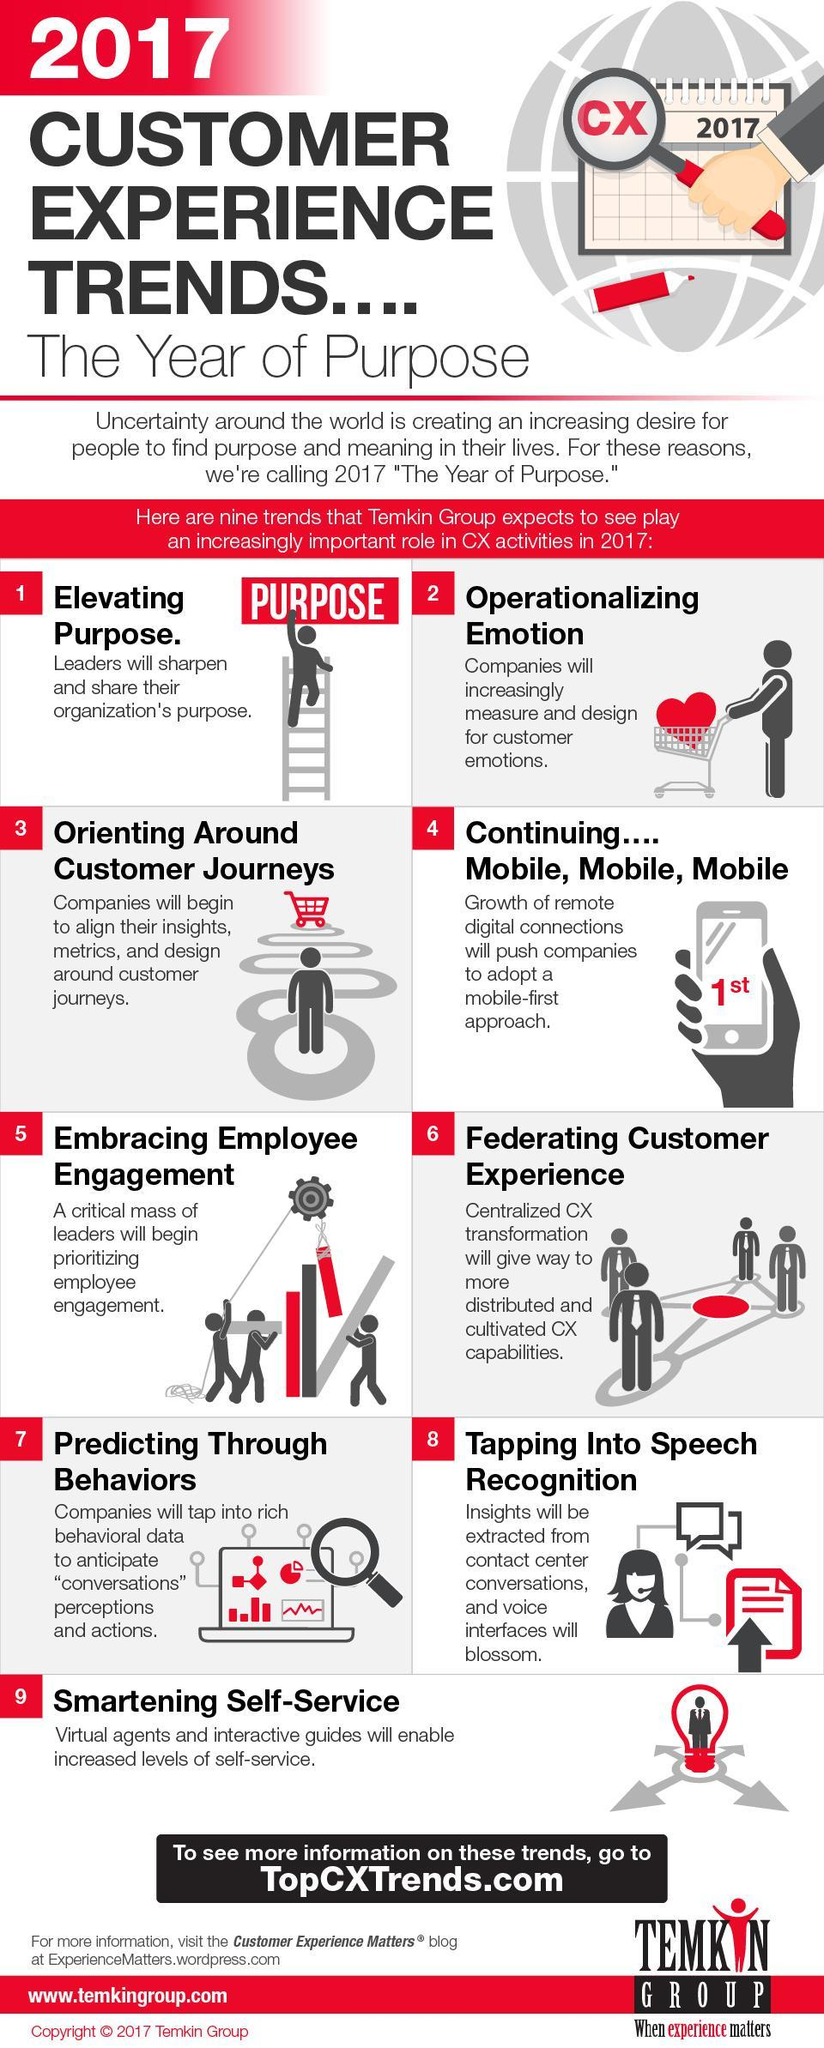Which trend makes user of voice related data, Behavioral data, Speech Recognition or Smart Self Service?
Answer the question with a short phrase. Speech recognition Which trend taps into customers behavioral pattern? Trend 7 